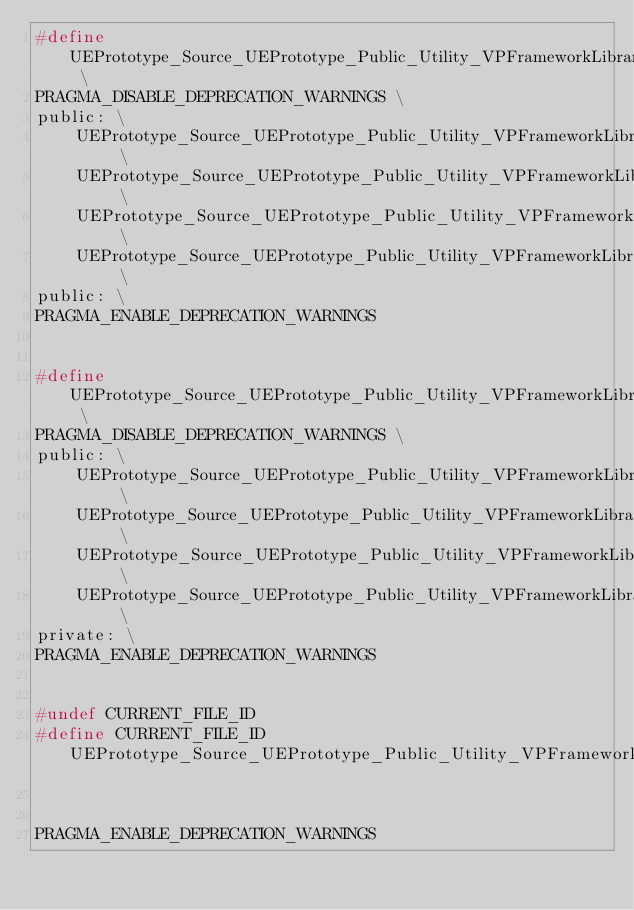Convert code to text. <code><loc_0><loc_0><loc_500><loc_500><_C_>#define UEPrototype_Source_UEPrototype_Public_Utility_VPFrameworkLibrary_h_15_GENERATED_BODY_LEGACY \
PRAGMA_DISABLE_DEPRECATION_WARNINGS \
public: \
	UEPrototype_Source_UEPrototype_Public_Utility_VPFrameworkLibrary_h_15_PRIVATE_PROPERTY_OFFSET \
	UEPrototype_Source_UEPrototype_Public_Utility_VPFrameworkLibrary_h_15_RPC_WRAPPERS \
	UEPrototype_Source_UEPrototype_Public_Utility_VPFrameworkLibrary_h_15_INCLASS \
	UEPrototype_Source_UEPrototype_Public_Utility_VPFrameworkLibrary_h_15_STANDARD_CONSTRUCTORS \
public: \
PRAGMA_ENABLE_DEPRECATION_WARNINGS


#define UEPrototype_Source_UEPrototype_Public_Utility_VPFrameworkLibrary_h_15_GENERATED_BODY \
PRAGMA_DISABLE_DEPRECATION_WARNINGS \
public: \
	UEPrototype_Source_UEPrototype_Public_Utility_VPFrameworkLibrary_h_15_PRIVATE_PROPERTY_OFFSET \
	UEPrototype_Source_UEPrototype_Public_Utility_VPFrameworkLibrary_h_15_RPC_WRAPPERS_NO_PURE_DECLS \
	UEPrototype_Source_UEPrototype_Public_Utility_VPFrameworkLibrary_h_15_INCLASS_NO_PURE_DECLS \
	UEPrototype_Source_UEPrototype_Public_Utility_VPFrameworkLibrary_h_15_ENHANCED_CONSTRUCTORS \
private: \
PRAGMA_ENABLE_DEPRECATION_WARNINGS


#undef CURRENT_FILE_ID
#define CURRENT_FILE_ID UEPrototype_Source_UEPrototype_Public_Utility_VPFrameworkLibrary_h


PRAGMA_ENABLE_DEPRECATION_WARNINGS
</code> 